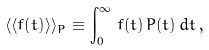Convert formula to latex. <formula><loc_0><loc_0><loc_500><loc_500>\langle \langle { f ( t ) } \rangle \rangle _ { P } \equiv \int _ { 0 } ^ { \infty } \, f ( t ) \, P ( t ) \, d t \, ,</formula> 